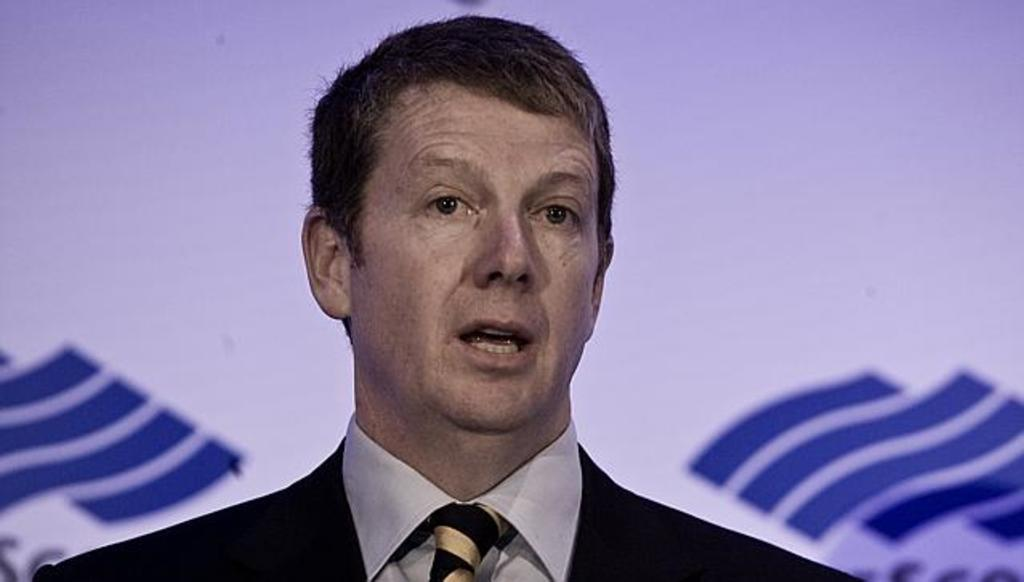Who is present in the image? There is a man in the image. What can be seen in the background of the image? There is a banner in the background of the image. What is the weight of the box in the image? There is no box present in the image, so it is not possible to determine its weight. 